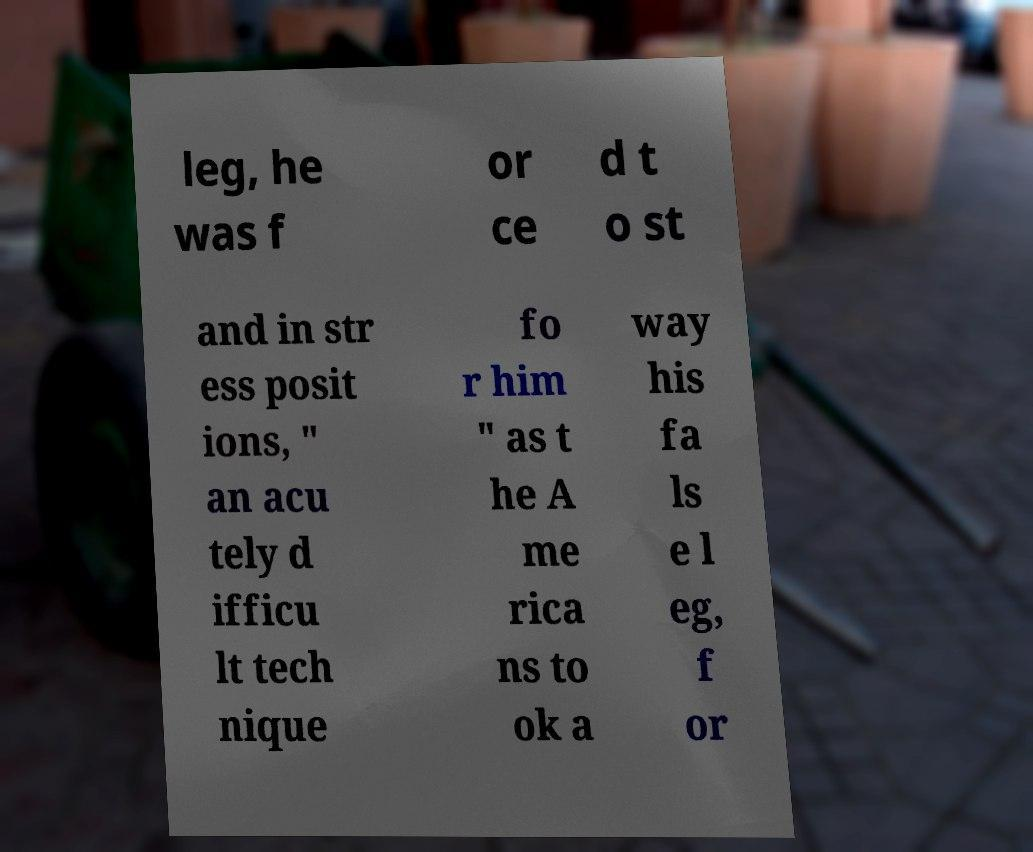For documentation purposes, I need the text within this image transcribed. Could you provide that? leg, he was f or ce d t o st and in str ess posit ions, " an acu tely d ifficu lt tech nique fo r him " as t he A me rica ns to ok a way his fa ls e l eg, f or 